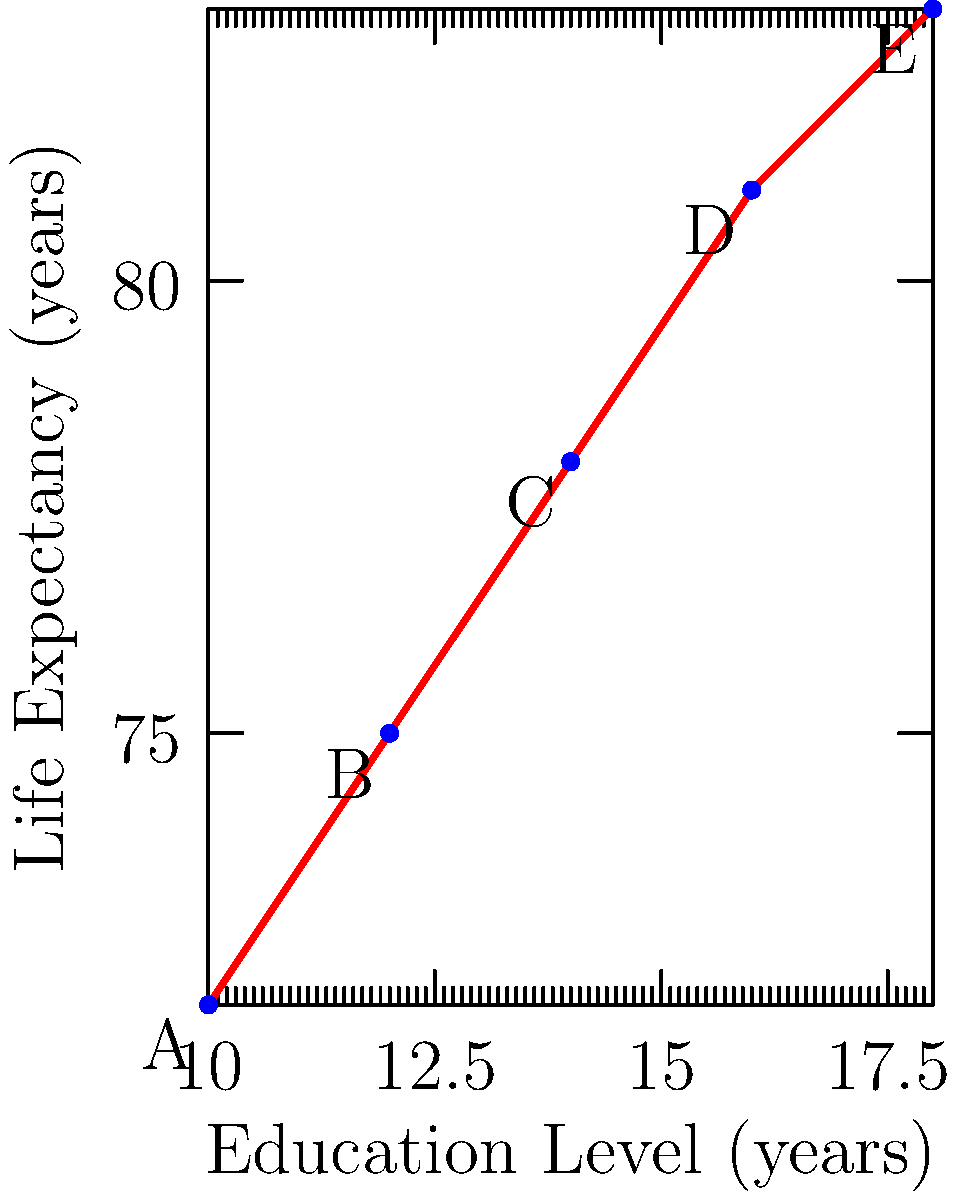The vector plot above shows the relationship between education levels and life expectancy in five different populations (A, B, C, D, and E). Based on your expertise in health inequalities, what can be inferred about the correlation between education and life expectancy, and how would you quantify this relationship using vector analysis? To analyze the correlation between education levels and life expectancy using vector analysis, we can follow these steps:

1. Identify the vectors: Each point represents a vector from the origin to (education level, life expectancy).

2. Calculate the direction vectors:
   We can use the vector from A to E to represent the overall trend.
   $\vec{v} = (18-10, 83-72) = (8, 11)$

3. Normalize the direction vector:
   $\vec{u} = \frac{\vec{v}}{|\vec{v}|} = \frac{(8, 11)}{\sqrt{8^2 + 11^2}} \approx (0.59, 0.81)$

4. Analyze the correlation:
   The positive components in both dimensions indicate a positive correlation.
   The larger y-component (0.81) compared to the x-component (0.59) suggests that life expectancy increases more rapidly than education level.

5. Calculate the angle of the trend line:
   $\theta = \arctan(\frac{11}{8}) \approx 54.0°$

6. Interpret the results:
   The angle being closer to 90° than 45° confirms that life expectancy increases more steeply relative to education level.

7. Quantify the relationship:
   We can use the slope of the trend line: $m = \frac{83-72}{18-10} = \frac{11}{8} = 1.375$
   This means that, on average, for every additional year of education, life expectancy increases by 1.375 years.

8. Consider sociological implications:
   This strong positive correlation suggests that policies promoting education could have significant impacts on population health and longevity.
Answer: Strong positive correlation; slope = 1.375 years of life expectancy per year of education 